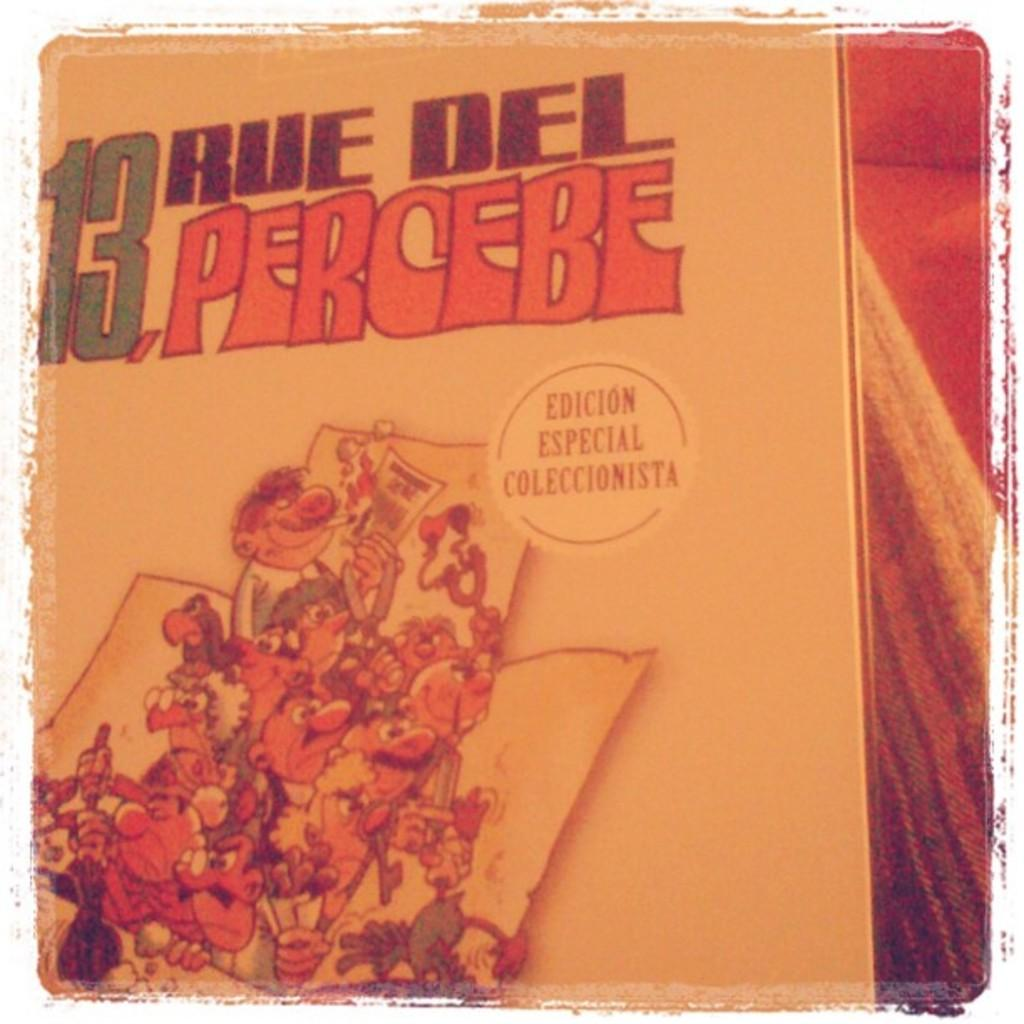<image>
Present a compact description of the photo's key features. A book cover saying 13 rue del percebe on it 